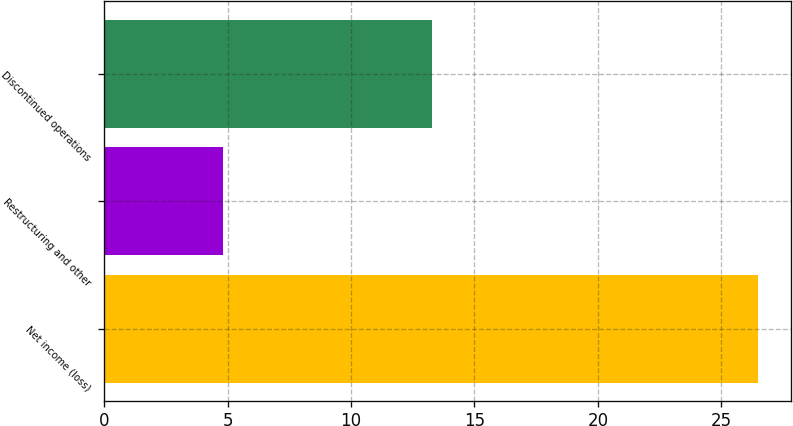<chart> <loc_0><loc_0><loc_500><loc_500><bar_chart><fcel>Net income (loss)<fcel>Restructuring and other<fcel>Discontinued operations<nl><fcel>26.5<fcel>4.8<fcel>13.3<nl></chart> 